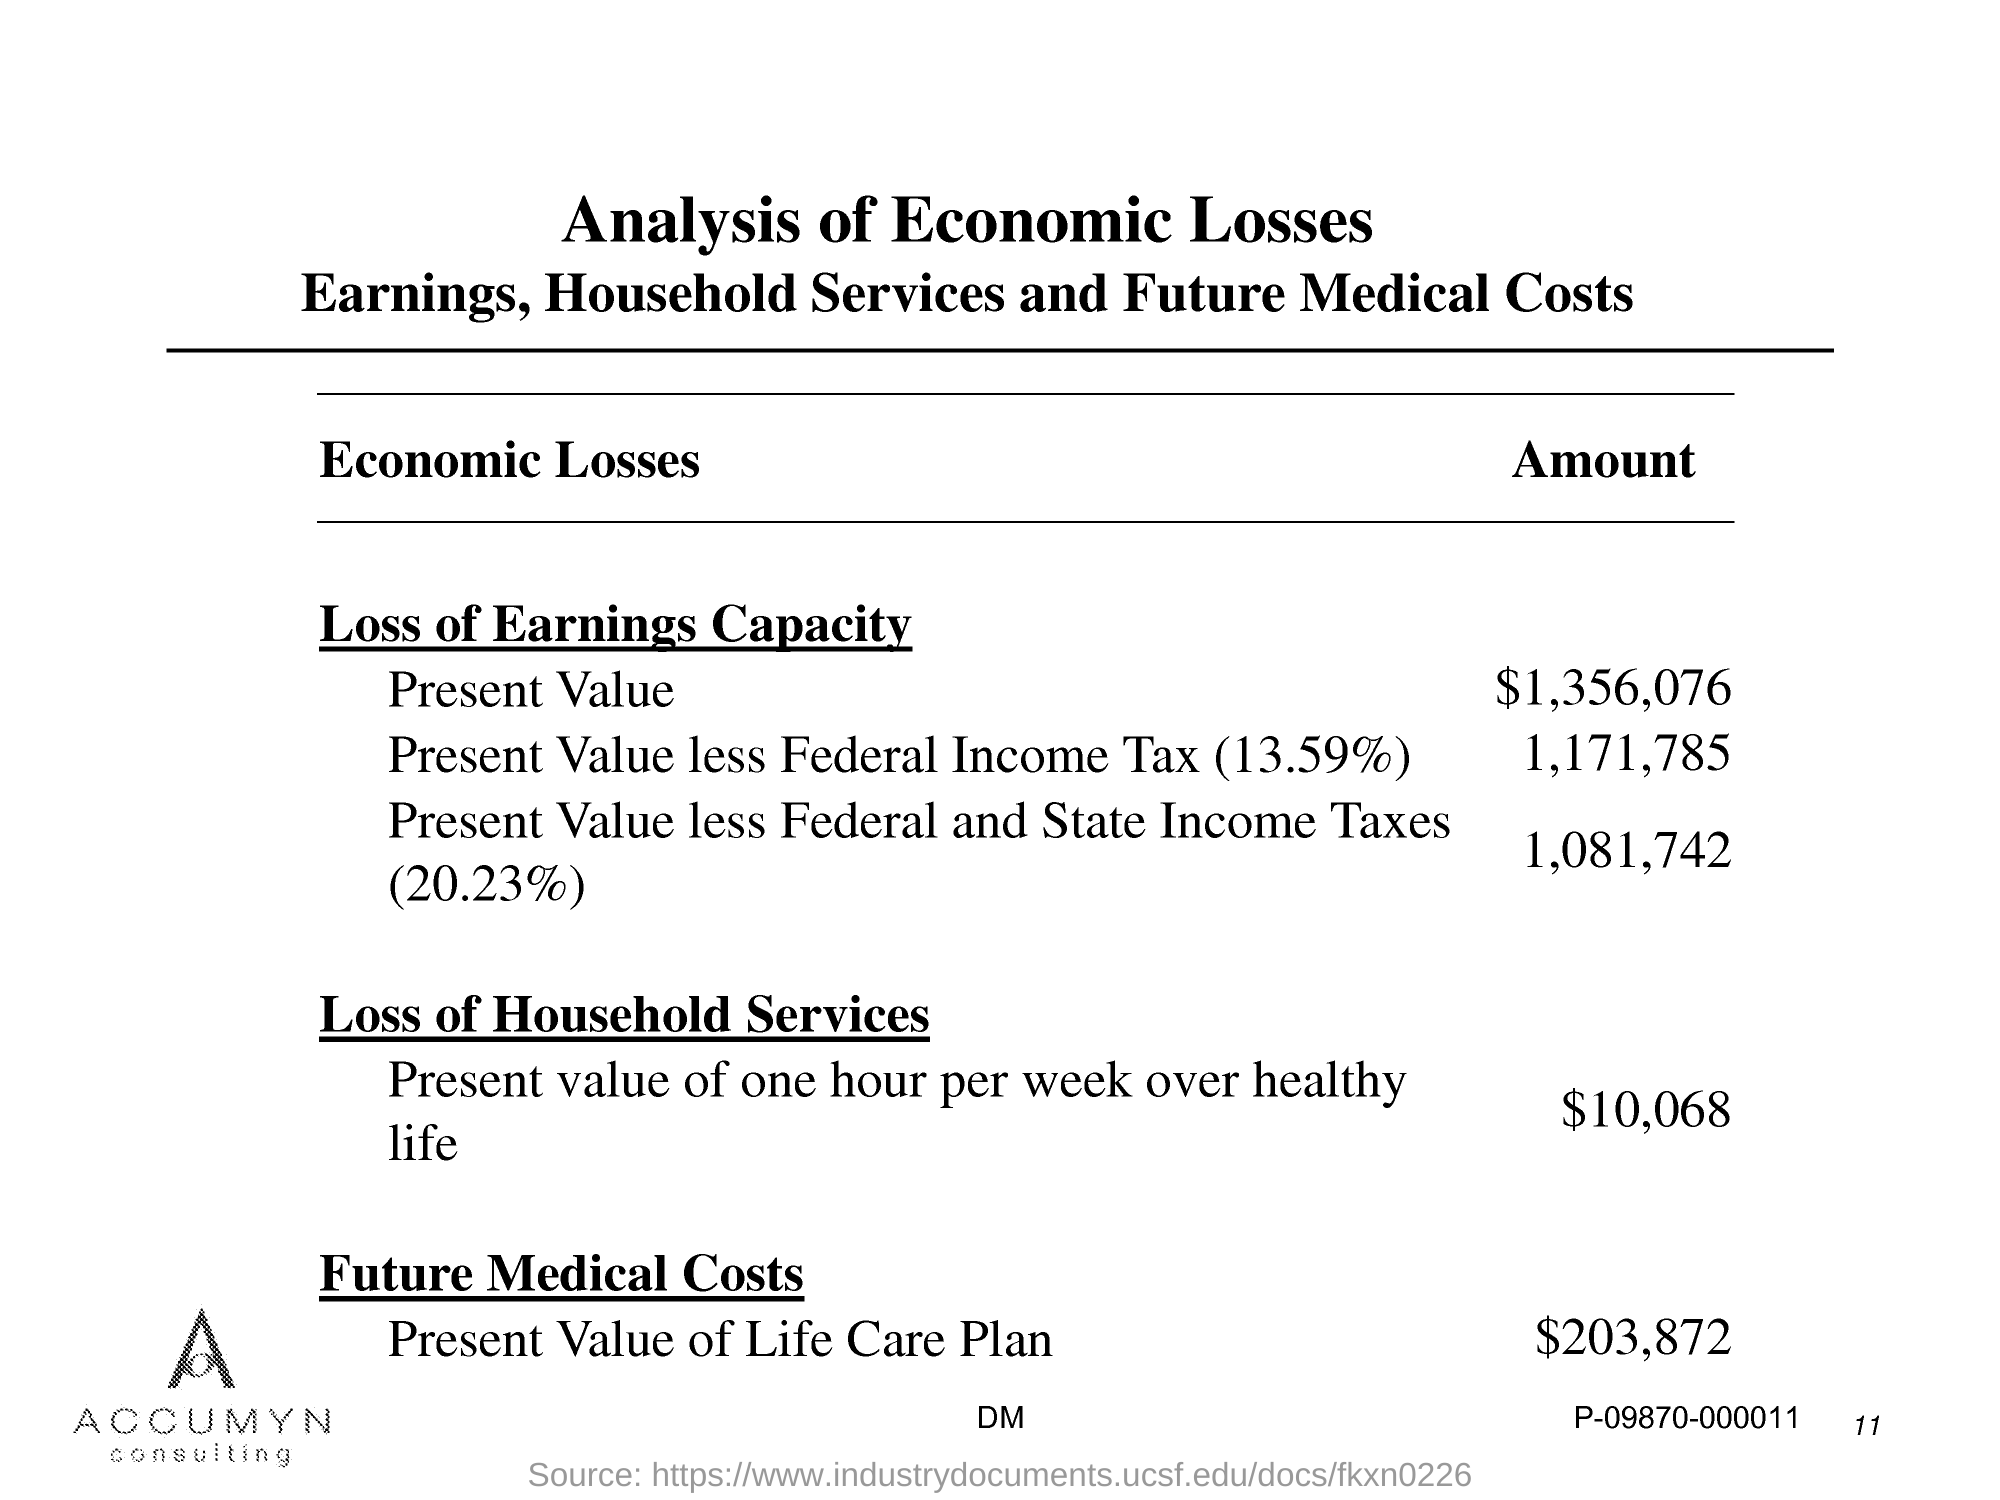What is the amount of present value?
Ensure brevity in your answer.  $1,356,076. What is the amount of present value less federal income tax ?
Provide a short and direct response. 1,171,785. What is the amount of present value less federal and state  income taxes ?
Keep it short and to the point. 1,081,742. What is the amount of present value of one hour per week over healthy life?
Your response must be concise. $10,068. What is the amount of present value of life care plan ?
Ensure brevity in your answer.  $203,872. 